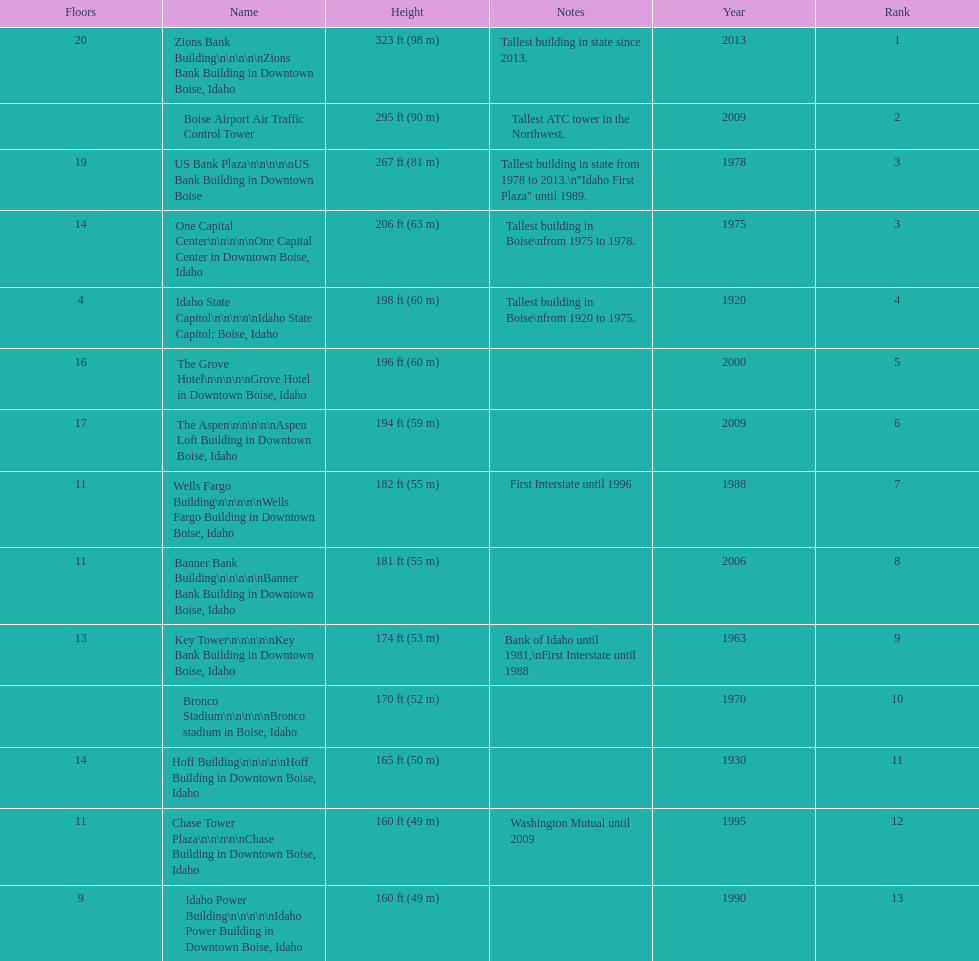How many buildings have at least ten floors? 10. 